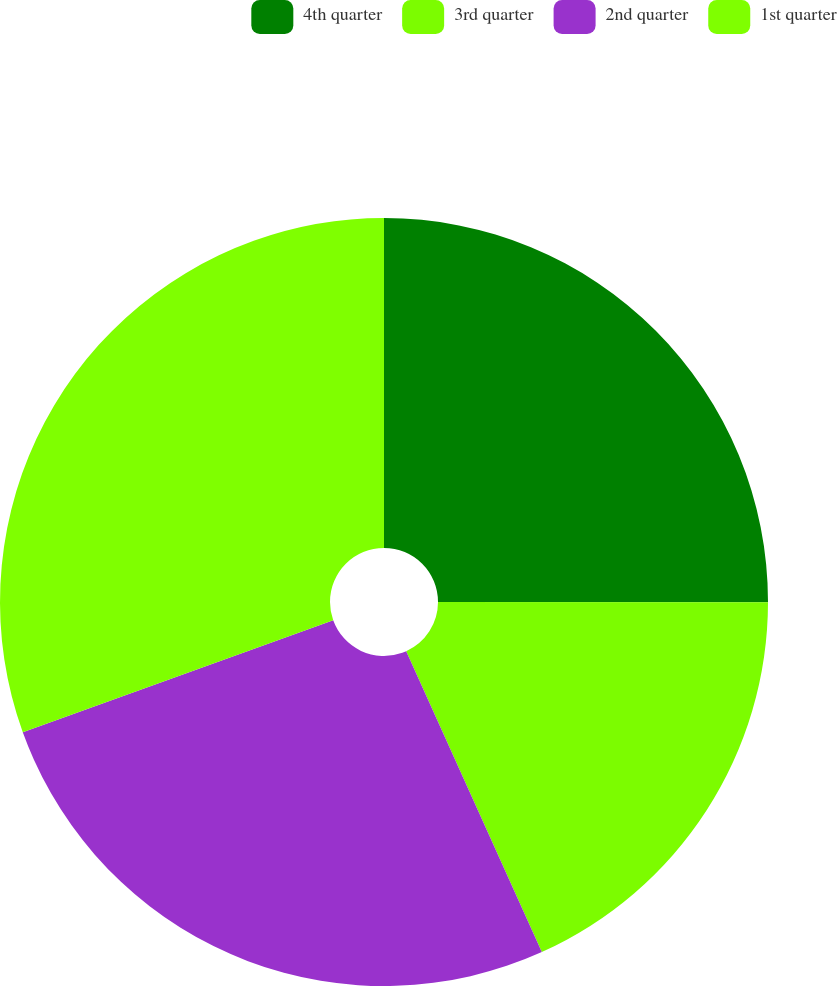Convert chart. <chart><loc_0><loc_0><loc_500><loc_500><pie_chart><fcel>4th quarter<fcel>3rd quarter<fcel>2nd quarter<fcel>1st quarter<nl><fcel>25.01%<fcel>18.25%<fcel>26.23%<fcel>30.51%<nl></chart> 